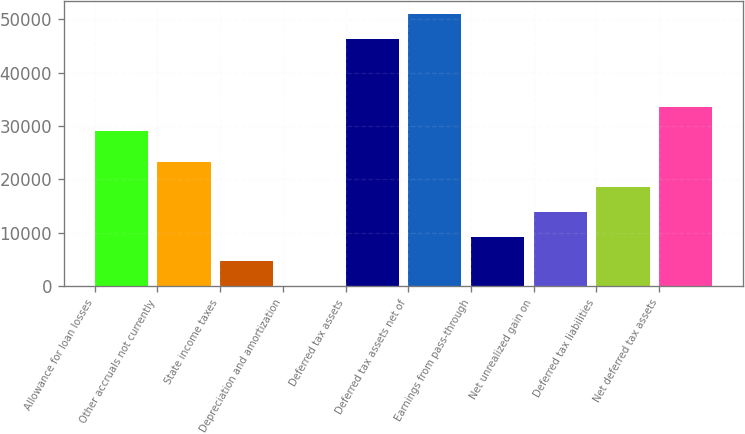<chart> <loc_0><loc_0><loc_500><loc_500><bar_chart><fcel>Allowance for loan losses<fcel>Other accruals not currently<fcel>State income taxes<fcel>Depreciation and amortization<fcel>Deferred tax assets<fcel>Deferred tax assets net of<fcel>Earnings from pass-through<fcel>Net unrealized gain on<fcel>Deferred tax liabilities<fcel>Net deferred tax assets<nl><fcel>29030<fcel>23172.5<fcel>4652.9<fcel>23<fcel>46322<fcel>50951.9<fcel>9282.8<fcel>13912.7<fcel>18542.6<fcel>33659.9<nl></chart> 